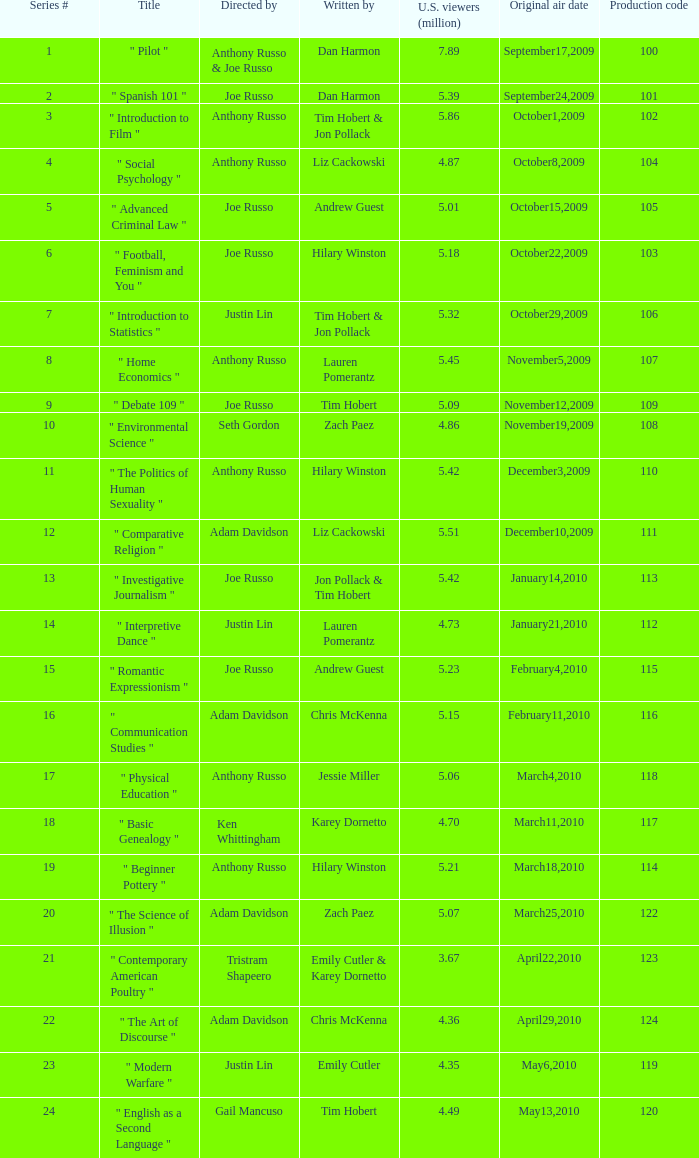What is the highest series # directed by ken whittingham? 18.0. 